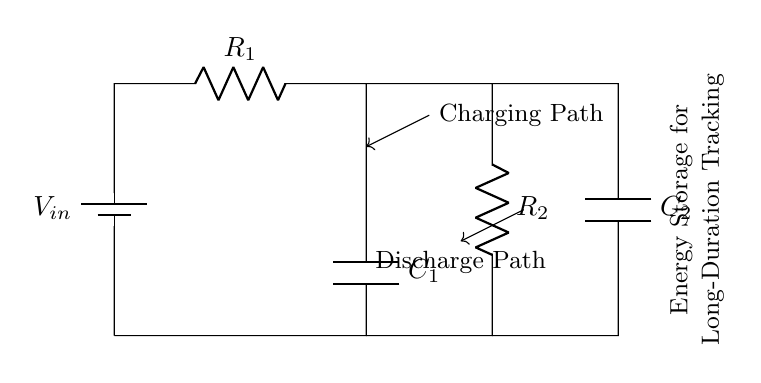What is the total number of resistors in the circuit? There are two resistors in the circuit: R1 and R2, both clearly labeled.
Answer: 2 What is the type of energy storage component used in this circuit? The circuit contains two capacitors, C1 and C2, which are specifically designed for energy storage.
Answer: Capacitor What is the primary function of C1 in this circuit? C1 is used for energy storage during the charging phase of the circuit. It captures energy and holds it for later use.
Answer: Energy storage What configuration are R1 and C1 in? R1 is in series with C1, as the components are connected end-to-end, forming a single path for current flow.
Answer: Series What happens during the discharge path in this circuit? During the discharge path, the stored energy in the capacitors is released, providing current to the load or circuit downstream.
Answer: Energy release How do the resistors affect the charging time of the capacitors? The resistors R1 and R2 limit the current flowing into the capacitors, affecting the time it takes for them to charge fully, with higher resistance resulting in longer charging times.
Answer: Increase charging time 